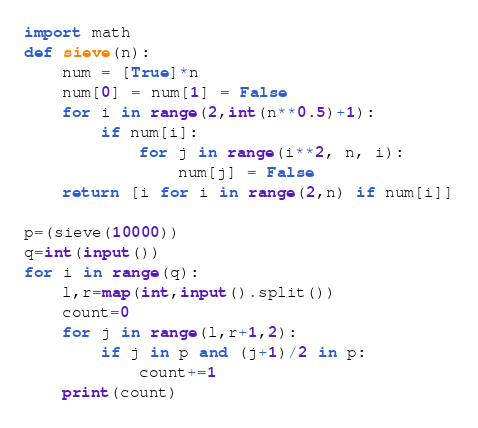Convert code to text. <code><loc_0><loc_0><loc_500><loc_500><_Python_>import math
def sieve(n):
    num = [True]*n
    num[0] = num[1] = False
    for i in range(2,int(n**0.5)+1):
        if num[i]:
            for j in range(i**2, n, i):
                num[j] = False
    return [i for i in range(2,n) if num[i]]

p=(sieve(10000))
q=int(input())
for i in range(q):
    l,r=map(int,input().split())
    count=0
    for j in range(l,r+1,2):
        if j in p and (j+1)/2 in p:
            count+=1
    print(count)</code> 